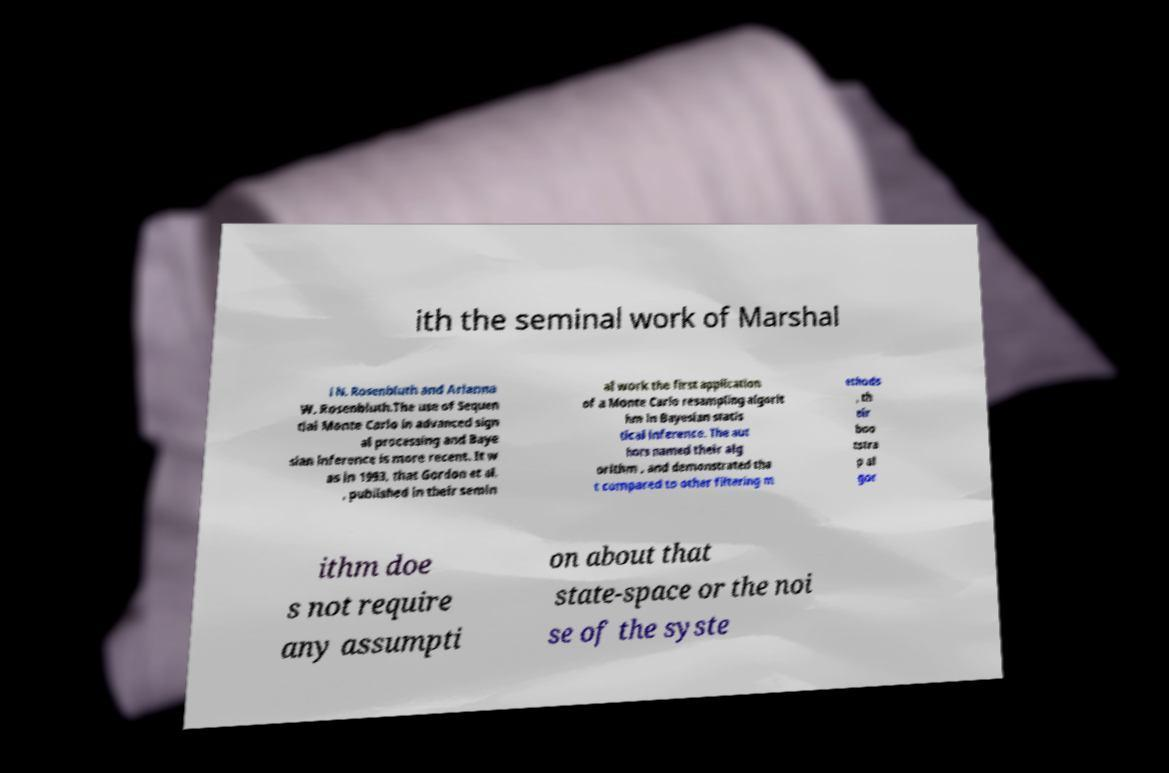Can you accurately transcribe the text from the provided image for me? ith the seminal work of Marshal l N. Rosenbluth and Arianna W. Rosenbluth.The use of Sequen tial Monte Carlo in advanced sign al processing and Baye sian inference is more recent. It w as in 1993, that Gordon et al. , published in their semin al work the first application of a Monte Carlo resampling algorit hm in Bayesian statis tical inference. The aut hors named their alg orithm , and demonstrated tha t compared to other filtering m ethods , th eir boo tstra p al gor ithm doe s not require any assumpti on about that state-space or the noi se of the syste 